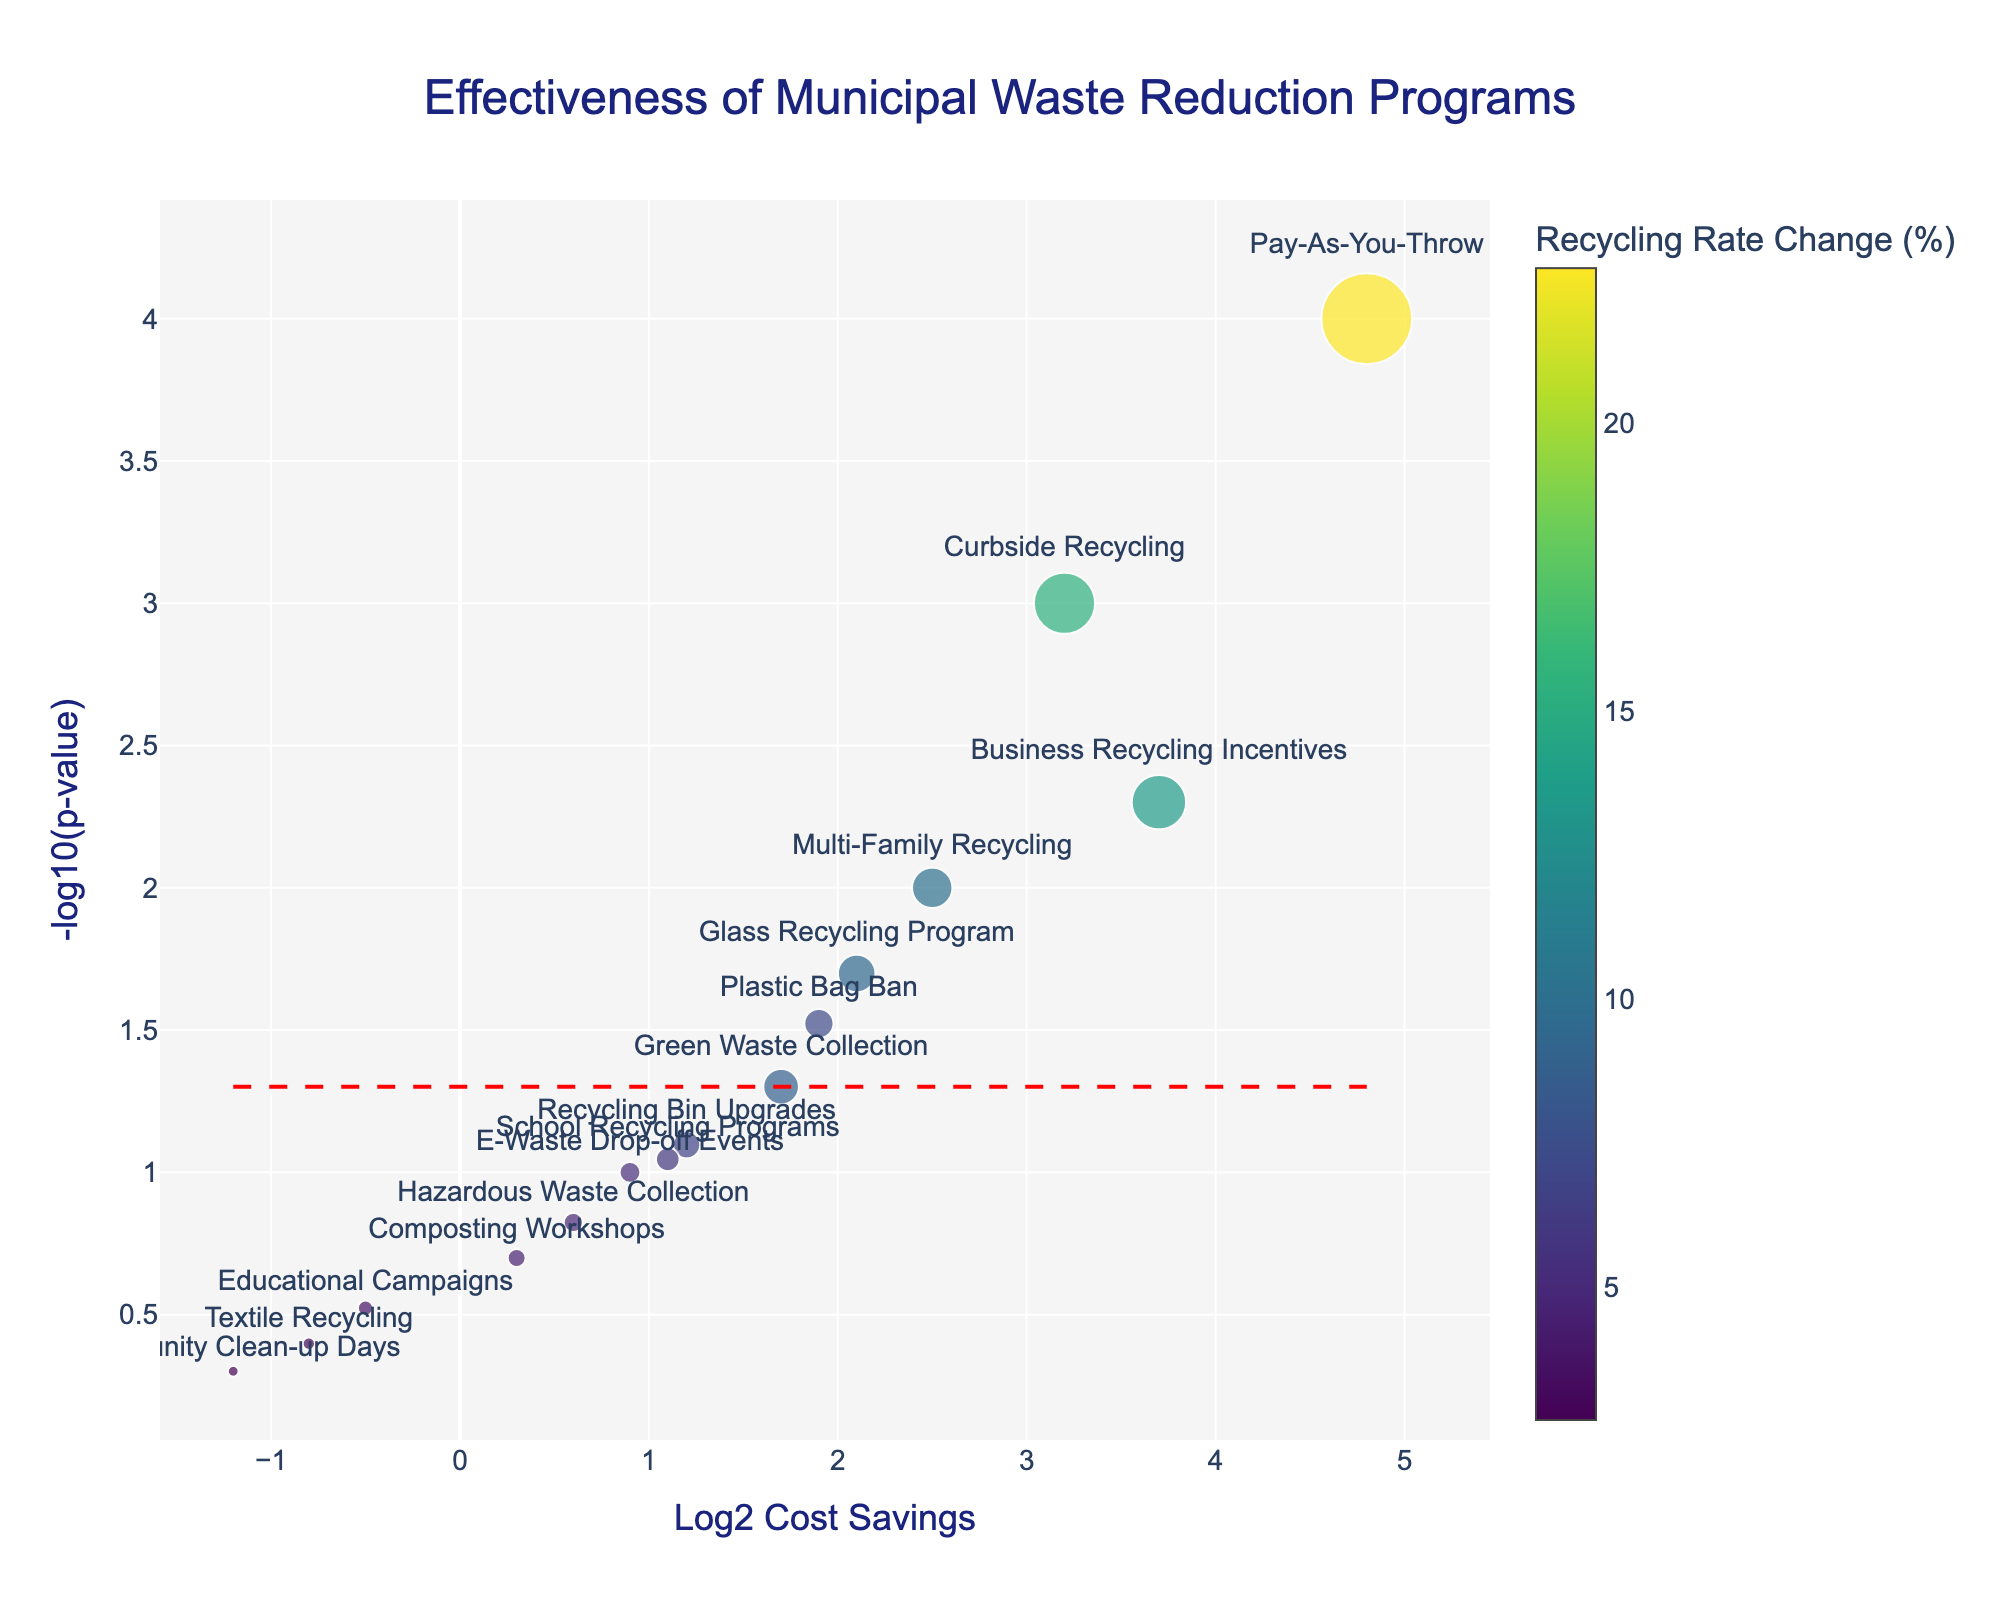How many programs are depicted in the figure? By counting the number of distinct data points (markers) in the plot, we can determine the total number of programs represented.
Answer: 15 What does the x-axis represent in the figure? The x-axis of the plot is labeled "Log2 Cost Savings," which indicates it represents the base 2 logarithm of the cost savings for each program.
Answer: Log2 Cost Savings Which program has the highest recycling rate change? By looking at the marker sizes, the program with the largest marker corresponds to "Pay-As-You-Throw," which has the highest recycling rate change of 22.7%.
Answer: Pay-As-You-Throw What value on the y-axis represents the significance threshold? The red dashed line indicates the significance threshold, drawn at -log10(p-value) = 1.3. This corresponds to the p-value of 0.05.
Answer: 1.3 Which programs lie above the significance threshold? Programs with markers above the red dashed line (-log10(p-value) > 1.3) are statistically significant. By inspecting these markers, the programs are "Curbside Recycling," "Pay-As-You-Throw," "Multi-Family Recycling," "Business Recycling Incentives," "Glass Recycling Program," and "Plastic Bag Ban."
Answer: 6 programs What is the y-axis value for the "Green Waste Collection" program? Locate the "Green Waste Collection" marker and refer to its position on the y-axis, which represents -log10(p-value). The y-axis value is 1.3.
Answer: 1.3 Which program has a Log2 Cost Savings closest to zero and is it above or below the significance threshold? Identify the marker closest to the zero value on the x-axis, "Composting Workshops." Then check its y-axis value against the red dashed line. Its y-axis is below the 1.3 threshold.
Answer: Composting Workshops, below Is there any program with negative Log2 Cost Savings? If yes, which one has the lowest recycling rate change? Check markers on the left of the zero on the x-axis. Both "Educational Campaigns" and "Textile Recycling" have negative Log2 Cost Savings. "Community Clean-up Days" with -1.2 Log2 Cost Savings also has negative savings, and it has the lowest rate change of 2.7%.
Answer: Yes, Community Clean-up Days How does the "Plastic Bag Ban" program compare to the "Green Waste Collection" program in terms of statistical significance? Compare their positions on the y-axis, where "Plastic Bag Ban" is above -log10(0.05) indicating it is statistically significant, whereas "Green Waste Collection" lies exactly on -log10(0.05), indicating it is at the significance threshold.
Answer: Plastic Bag Ban is more significant What is the recycling rate change for "School Recycling Programs" and how significant is this program? Locate the "School Recycling Programs" marker. The hover text shows the recycling rate change is 5.9%. The y-axis value is 1.05 (below 1.3), suggesting it is not statistically significant.
Answer: 5.9%, not significant 